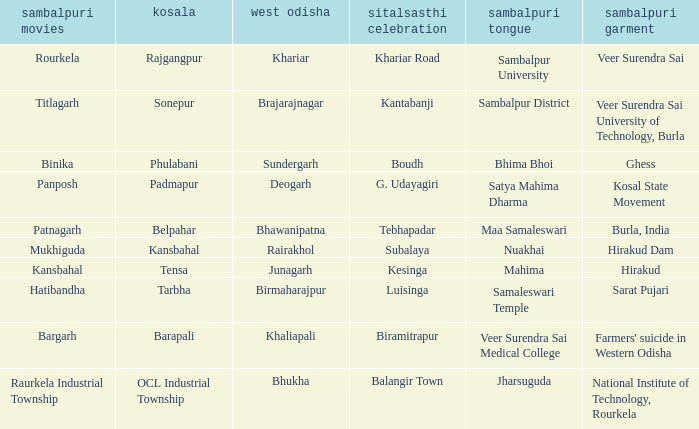What is the kosal with hatibandha as the sambalpuri cinema? Tarbha. 